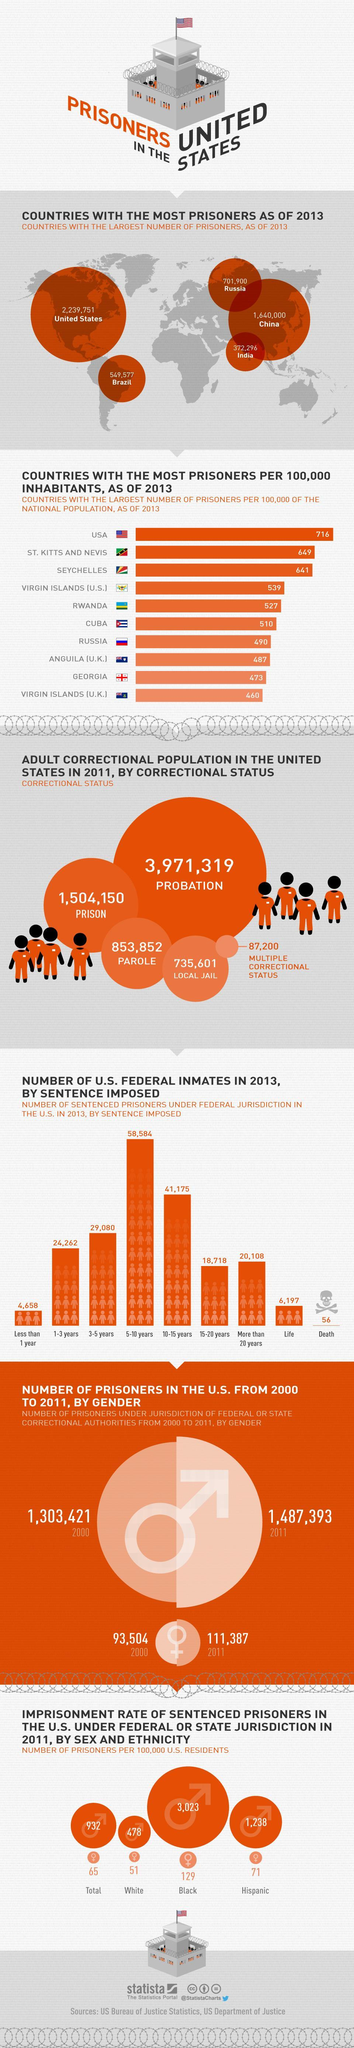What is the no of female prisoners under federal  jurisdiction in the U.S. in the year 2000?
Answer the question with a short phrase. 93,504 What is the no of prisoners in India as of 2013? 372,296 How many prisoners have imposed a life time sentence under federal jurisdiction in the U.S. in 2013? 6,197 How many prisoners have imposed a death sentence under federal jurisdiction in the U.S. in 2013? 56 What is the imprisonment rate of hispanic male prisoners in the U.S. under federal  or state jurisdiction in 2011? 1,238 What is the no of male prisoners under federal  jurisdiction in the U.S. in the year 2000? 1,303,421 What is the imprisonment rate of hispanic female prisoners in the U.S. under federal  or state jurisdiction in 2011? 71 How many prisoners went for parole from U.S. prison in 2011 as per the correctional status? 853,852 